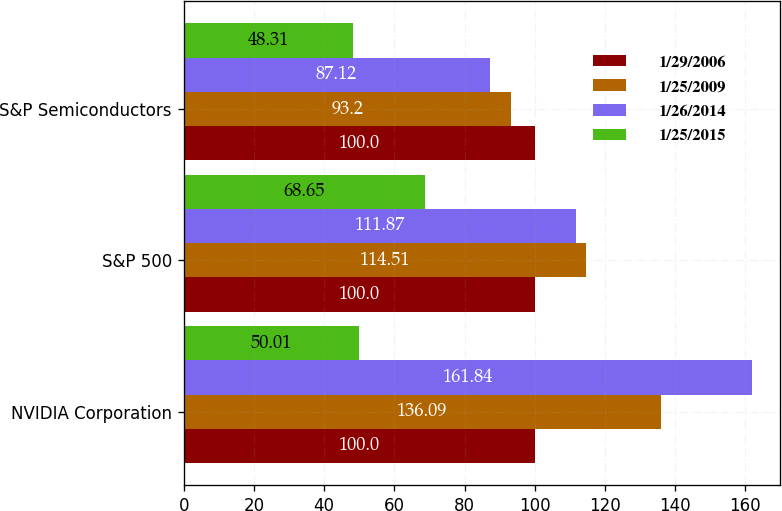Convert chart. <chart><loc_0><loc_0><loc_500><loc_500><stacked_bar_chart><ecel><fcel>NVIDIA Corporation<fcel>S&P 500<fcel>S&P Semiconductors<nl><fcel>1/29/2006<fcel>100<fcel>100<fcel>100<nl><fcel>1/25/2009<fcel>136.09<fcel>114.51<fcel>93.2<nl><fcel>1/26/2014<fcel>161.84<fcel>111.87<fcel>87.12<nl><fcel>1/25/2015<fcel>50.01<fcel>68.65<fcel>48.31<nl></chart> 